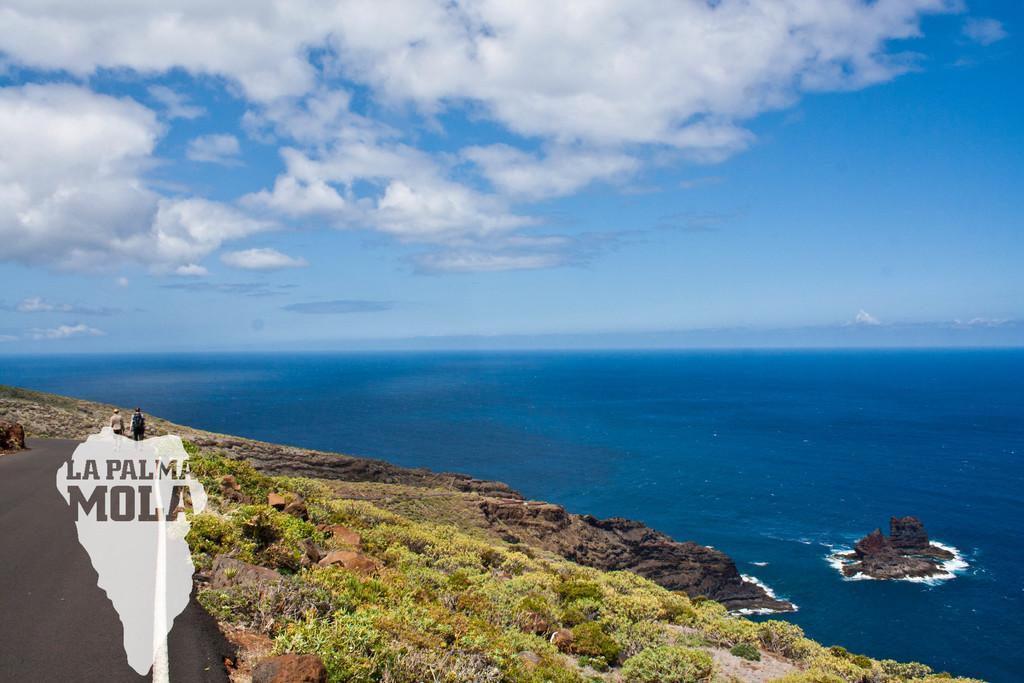In one or two sentences, can you explain what this image depicts? In this picture there is greenery at the bottom side of the image and there is sea in the center of the image. 